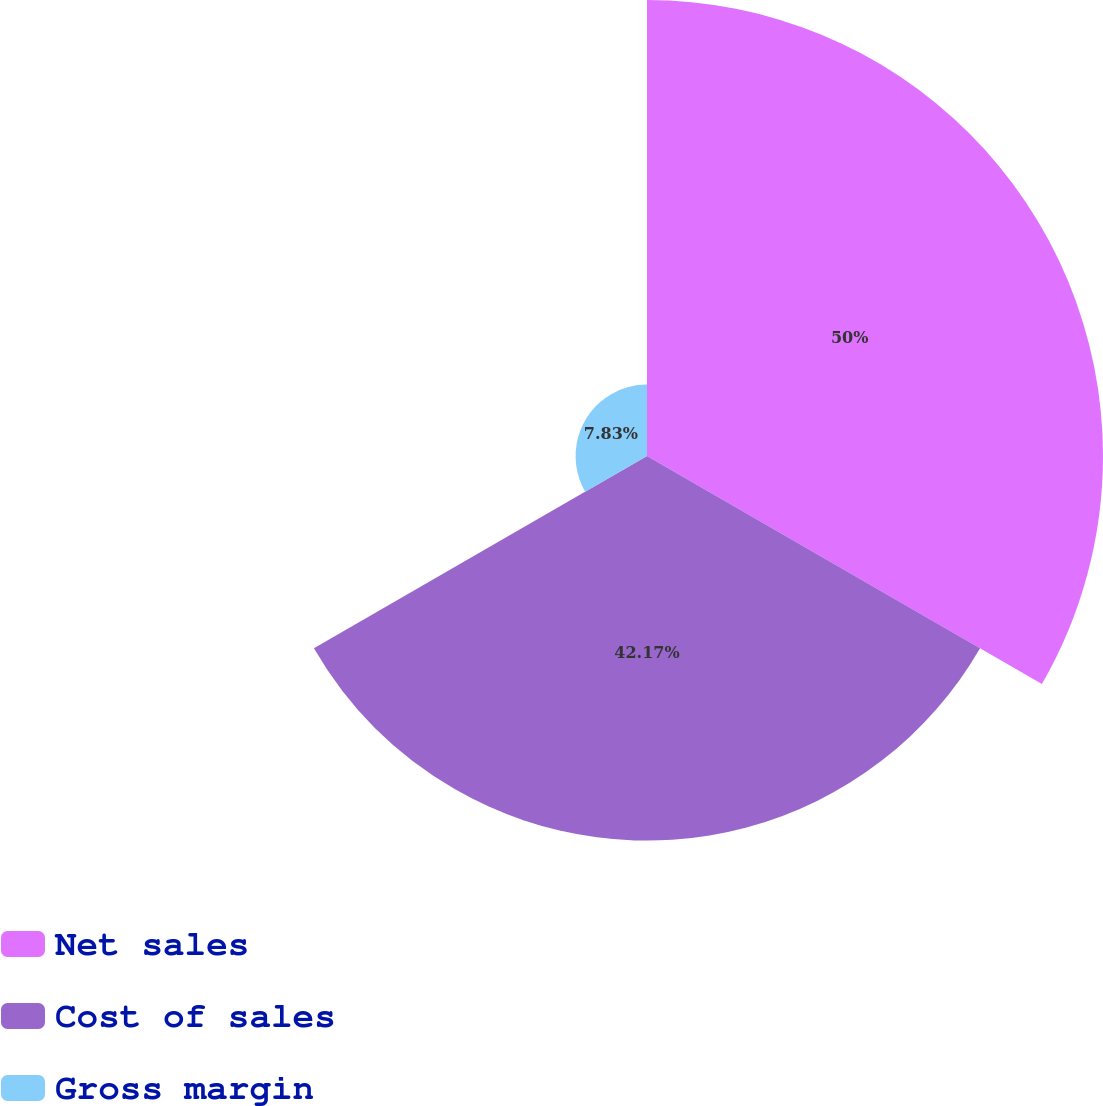<chart> <loc_0><loc_0><loc_500><loc_500><pie_chart><fcel>Net sales<fcel>Cost of sales<fcel>Gross margin<nl><fcel>50.0%<fcel>42.17%<fcel>7.83%<nl></chart> 